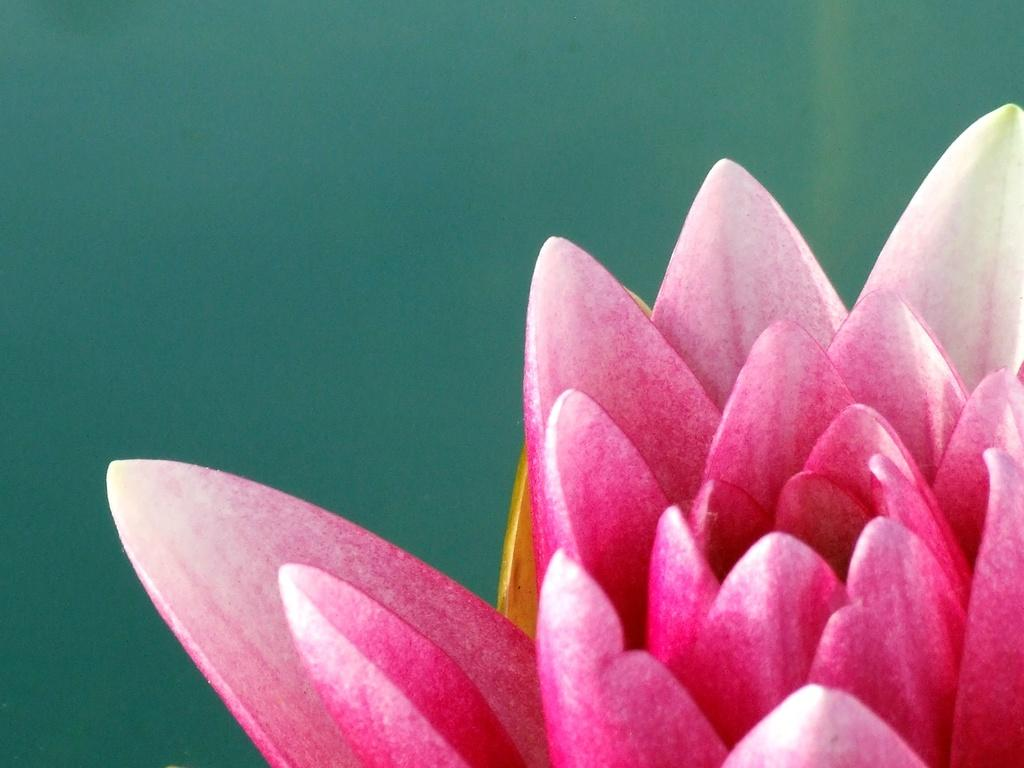What is the main subject of the image? There is a flower in the image. What color is the flower? The flower is pink in color. What can be seen in the background of the image? There is a green background in the image. How many cattle are grazing in the background of the image? There are no cattle present in the image; the background is green. What type of learning material is visible in the image? There is no learning material present in the image; it features a pink flower against a green background. 